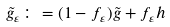<formula> <loc_0><loc_0><loc_500><loc_500>\tilde { g } _ { \varepsilon } \colon = ( 1 - f _ { \varepsilon } ) \tilde { g } + f _ { \varepsilon } h</formula> 